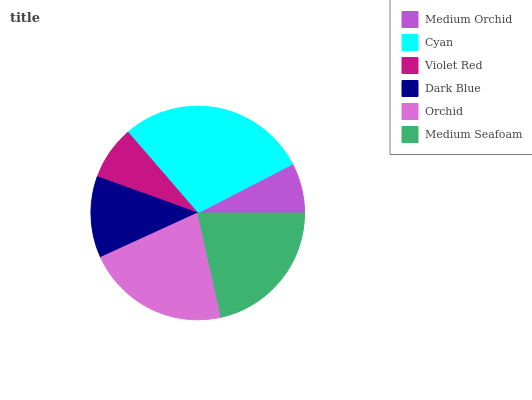Is Medium Orchid the minimum?
Answer yes or no. Yes. Is Cyan the maximum?
Answer yes or no. Yes. Is Violet Red the minimum?
Answer yes or no. No. Is Violet Red the maximum?
Answer yes or no. No. Is Cyan greater than Violet Red?
Answer yes or no. Yes. Is Violet Red less than Cyan?
Answer yes or no. Yes. Is Violet Red greater than Cyan?
Answer yes or no. No. Is Cyan less than Violet Red?
Answer yes or no. No. Is Medium Seafoam the high median?
Answer yes or no. Yes. Is Dark Blue the low median?
Answer yes or no. Yes. Is Cyan the high median?
Answer yes or no. No. Is Violet Red the low median?
Answer yes or no. No. 